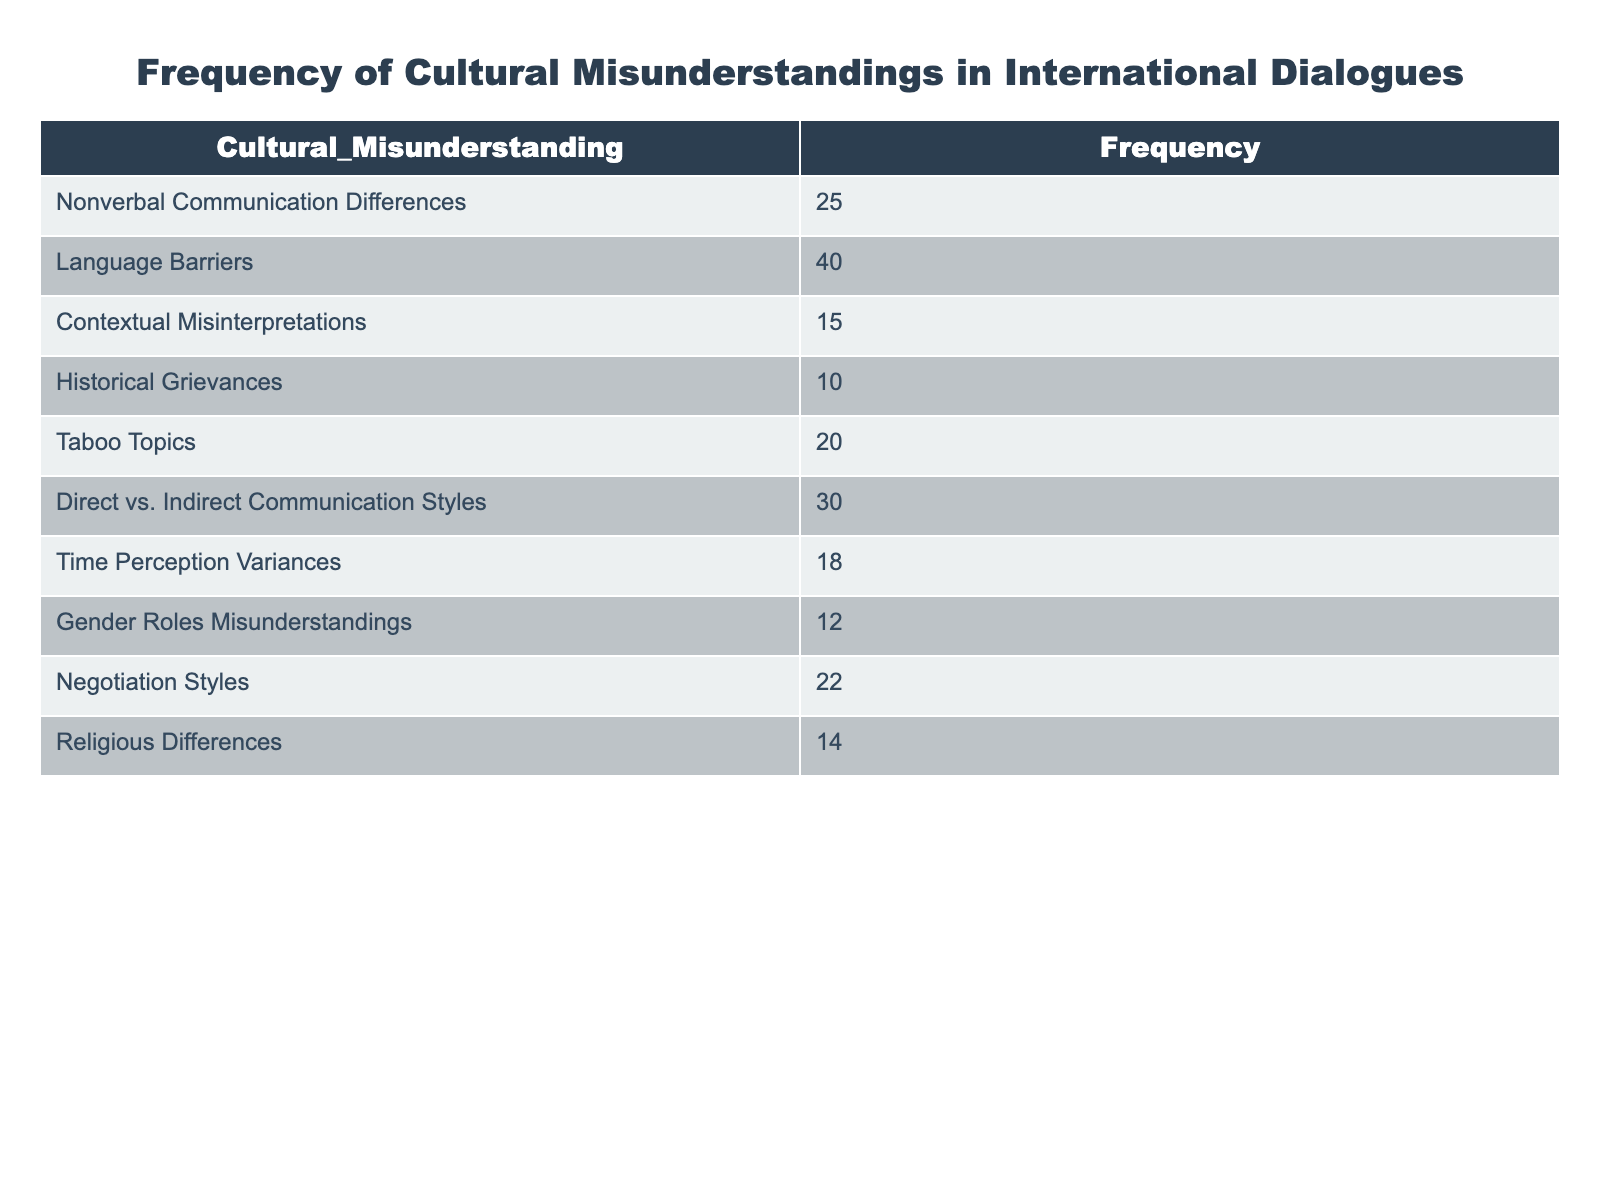What is the highest frequency of cultural misunderstanding listed in the table? The table displays various types of cultural misunderstandings alongside their frequencies. Scanning through the Frequency column, I identify the highest frequency is related to Language Barriers, which has a frequency of 40.
Answer: 40 Which cultural misunderstanding has the lowest frequency? By examining the Frequency column of the table, I can see that Historical Grievances is listed with the lowest frequency of 10.
Answer: 10 What is the total frequency of misunderstandings related to communication styles (Direct vs. Indirect Communication Styles and Nonverbal Communication Differences)? To find the total frequency related to communication styles, I need to add the two relevant frequencies: Nonverbal Communication Differences (25) and Direct vs. Indirect Communication Styles (30). Therefore, the total is 25 + 30 = 55.
Answer: 55 How many misunderstandings have a frequency greater than 20? I will count the number of misunderstandings with frequencies greater than 20 by checking each value in the Frequency column. The ones that qualify are Language Barriers (40), Direct vs. Indirect Communication Styles (30), Nonverbal Communication Differences (25), and Taboo Topics (20). This gives me four misunderstandings.
Answer: 4 Is it true that there are more misunderstandings related to Gender Roles than Religious Differences? I need to compare the frequencies of the two misunderstandings. Gender Roles Misunderstandings have a frequency of 12, while Religious Differences has a frequency of 14. Since 12 is less than 14, the statement is false.
Answer: False What is the average frequency of all the listed misunderstandings? To calculate the average frequency, first, I sum all the frequency values: 25 + 40 + 15 + 10 + 20 + 30 + 18 + 12 + 22 + 14 =  206. Next, since there are 10 categories, the average is 206 divided by 10, resulting in 20.6.
Answer: 20.6 Which misunderstanding category has a frequency closest to the average frequency? The average frequency is 20.6. By reviewing the frequencies in the table, I see that Time Perception Variances has a frequency of 18 and Taboo Topics has a frequency of 20; both are close to the average. Therefore, I will note that both of these are the closest.
Answer: 18 and 20 What is the difference in frequency between the highest and the lowest cultural misunderstandings? The highest frequency is for Language Barriers (40) and the lowest is for Historical Grievances (10). To find the difference, I subtract the lowest from the highest: 40 - 10 = 30.
Answer: 30 